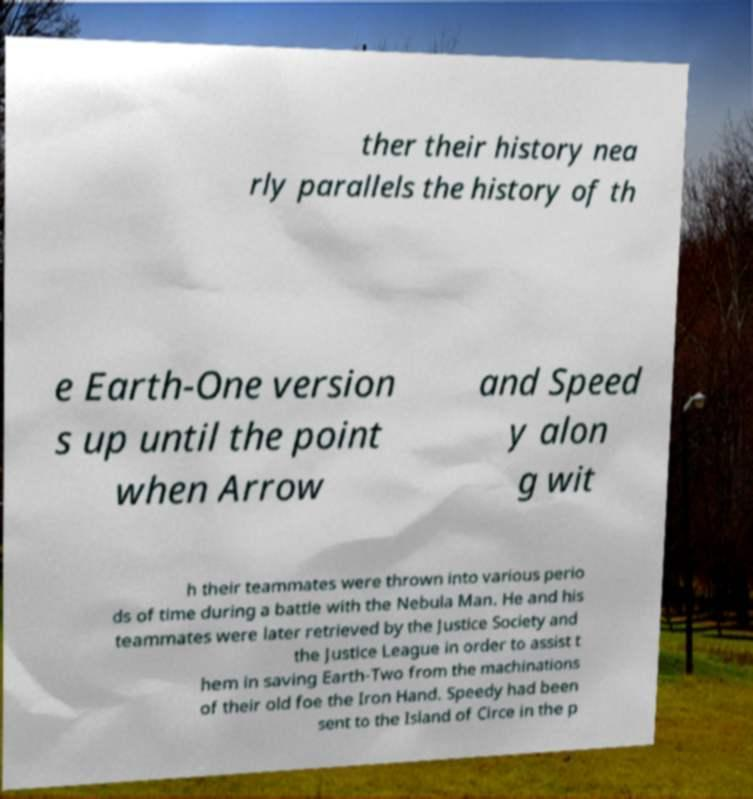What messages or text are displayed in this image? I need them in a readable, typed format. ther their history nea rly parallels the history of th e Earth-One version s up until the point when Arrow and Speed y alon g wit h their teammates were thrown into various perio ds of time during a battle with the Nebula Man. He and his teammates were later retrieved by the Justice Society and the Justice League in order to assist t hem in saving Earth-Two from the machinations of their old foe the Iron Hand. Speedy had been sent to the Island of Circe in the p 